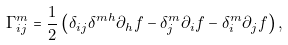<formula> <loc_0><loc_0><loc_500><loc_500>\Gamma _ { i j } ^ { m } = \frac { 1 } { 2 } \left ( \delta _ { i j } \delta ^ { m h } \partial _ { h } f - \delta ^ { m } _ { j } \partial _ { i } f - \delta _ { i } ^ { m } \partial _ { j } f \right ) ,</formula> 